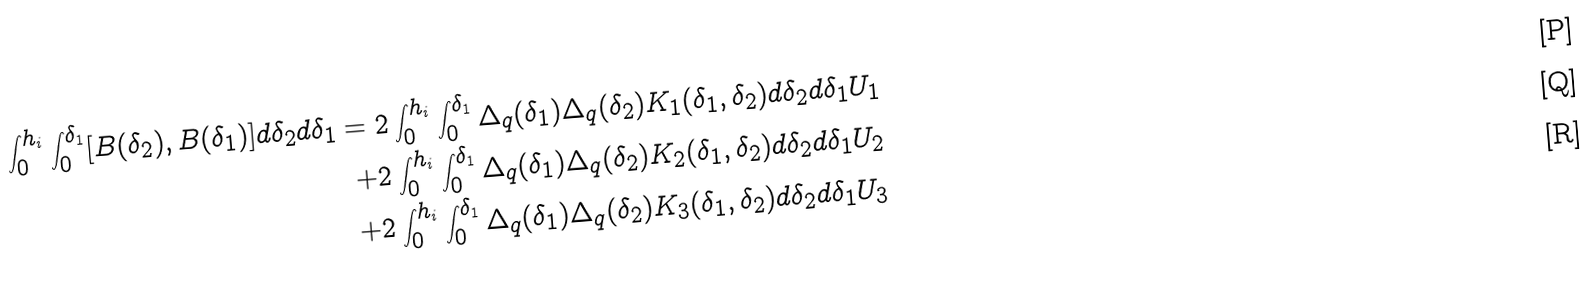Convert formula to latex. <formula><loc_0><loc_0><loc_500><loc_500>\int _ { 0 } ^ { h _ { i } } \int ^ { \delta _ { 1 } } _ { 0 } [ B ( \delta _ { 2 } ) , B ( \delta _ { 1 } ) ] d \delta _ { 2 } d \delta _ { 1 } = 2 \int _ { 0 } ^ { h _ { i } } \int ^ { \delta _ { 1 } } _ { 0 } \Delta _ { q } ( \delta _ { 1 } ) \Delta _ { q } ( \delta _ { 2 } ) K _ { 1 } ( \delta _ { 1 } , \delta _ { 2 } ) d \delta _ { 2 } d \delta _ { 1 } U _ { 1 } \\ + 2 \int _ { 0 } ^ { h _ { i } } \int ^ { \delta _ { 1 } } _ { 0 } \Delta _ { q } ( \delta _ { 1 } ) \Delta _ { q } ( \delta _ { 2 } ) K _ { 2 } ( \delta _ { 1 } , \delta _ { 2 } ) d \delta _ { 2 } d \delta _ { 1 } U _ { 2 } \\ + 2 \int _ { 0 } ^ { h _ { i } } \int ^ { \delta _ { 1 } } _ { 0 } \Delta _ { q } ( \delta _ { 1 } ) \Delta _ { q } ( \delta _ { 2 } ) K _ { 3 } ( \delta _ { 1 } , \delta _ { 2 } ) d \delta _ { 2 } d \delta _ { 1 } U _ { 3 }</formula> 